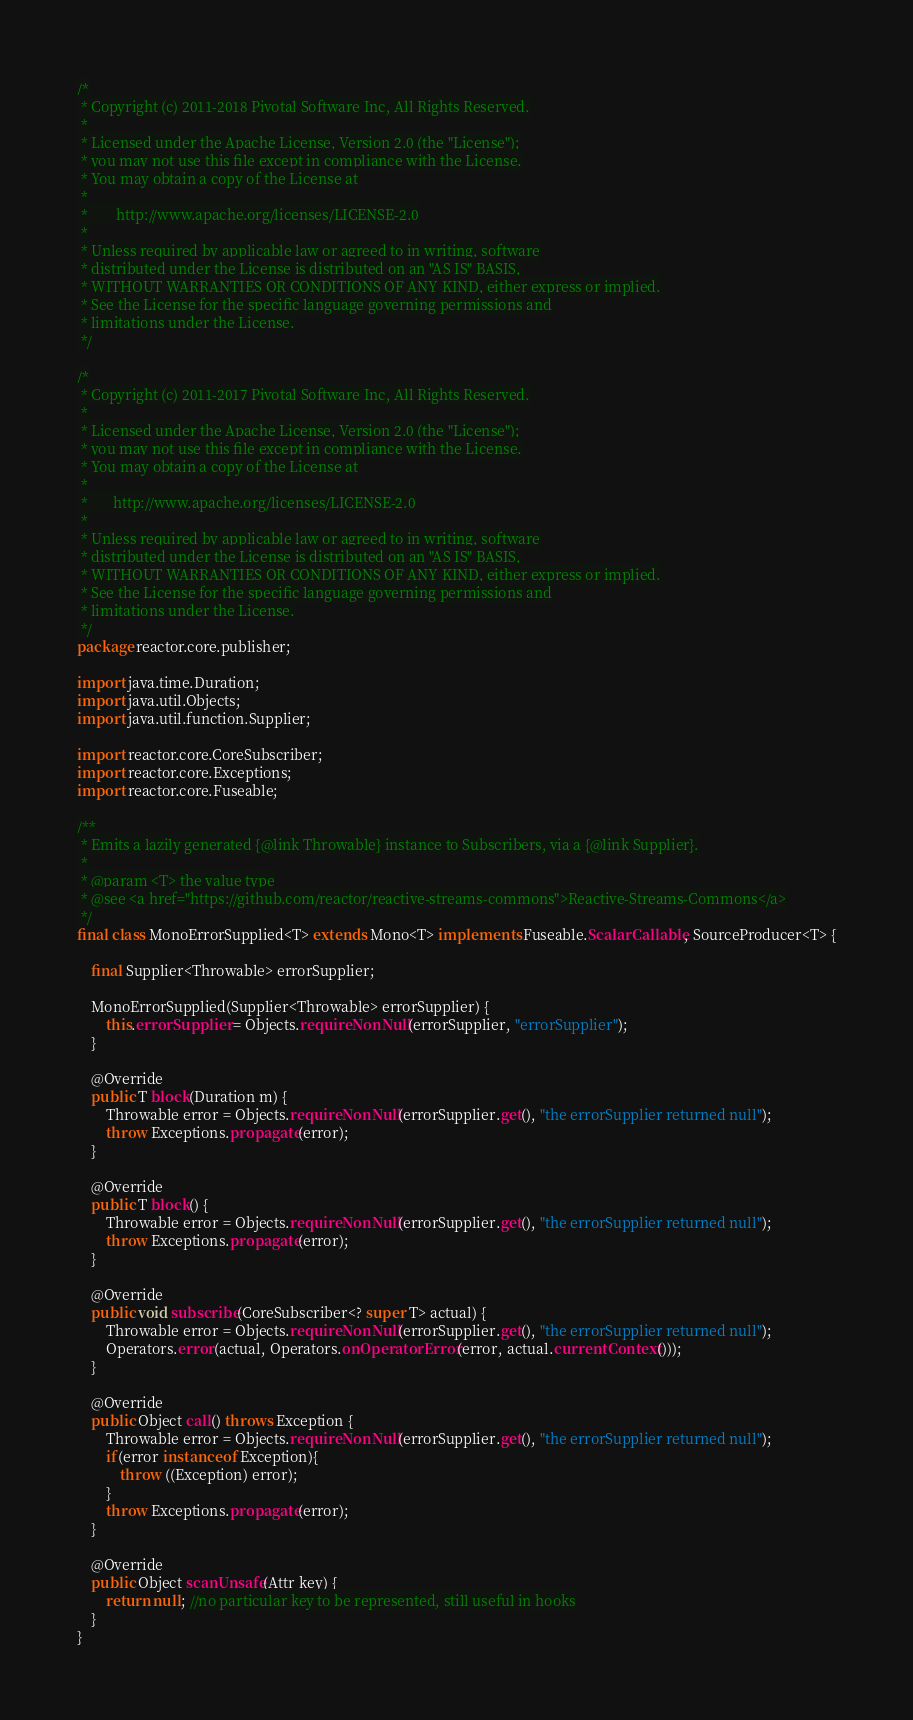<code> <loc_0><loc_0><loc_500><loc_500><_Java_>/*
 * Copyright (c) 2011-2018 Pivotal Software Inc, All Rights Reserved.
 *
 * Licensed under the Apache License, Version 2.0 (the "License");
 * you may not use this file except in compliance with the License.
 * You may obtain a copy of the License at
 *
 *        http://www.apache.org/licenses/LICENSE-2.0
 *
 * Unless required by applicable law or agreed to in writing, software
 * distributed under the License is distributed on an "AS IS" BASIS,
 * WITHOUT WARRANTIES OR CONDITIONS OF ANY KIND, either express or implied.
 * See the License for the specific language governing permissions and
 * limitations under the License.
 */

/*
 * Copyright (c) 2011-2017 Pivotal Software Inc, All Rights Reserved.
 *
 * Licensed under the Apache License, Version 2.0 (the "License");
 * you may not use this file except in compliance with the License.
 * You may obtain a copy of the License at
 *
 *       http://www.apache.org/licenses/LICENSE-2.0
 *
 * Unless required by applicable law or agreed to in writing, software
 * distributed under the License is distributed on an "AS IS" BASIS,
 * WITHOUT WARRANTIES OR CONDITIONS OF ANY KIND, either express or implied.
 * See the License for the specific language governing permissions and
 * limitations under the License.
 */
package reactor.core.publisher;

import java.time.Duration;
import java.util.Objects;
import java.util.function.Supplier;

import reactor.core.CoreSubscriber;
import reactor.core.Exceptions;
import reactor.core.Fuseable;

/**
 * Emits a lazily generated {@link Throwable} instance to Subscribers, via a {@link Supplier}.
 *
 * @param <T> the value type
 * @see <a href="https://github.com/reactor/reactive-streams-commons">Reactive-Streams-Commons</a>
 */
final class MonoErrorSupplied<T> extends Mono<T> implements Fuseable.ScalarCallable, SourceProducer<T> {

	final Supplier<Throwable> errorSupplier;

	MonoErrorSupplied(Supplier<Throwable> errorSupplier) {
		this.errorSupplier = Objects.requireNonNull(errorSupplier, "errorSupplier");
	}

	@Override
	public T block(Duration m) {
		Throwable error = Objects.requireNonNull(errorSupplier.get(), "the errorSupplier returned null");
		throw Exceptions.propagate(error);
	}

	@Override
	public T block() {
		Throwable error = Objects.requireNonNull(errorSupplier.get(), "the errorSupplier returned null");
		throw Exceptions.propagate(error);
	}

	@Override
	public void subscribe(CoreSubscriber<? super T> actual) {
		Throwable error = Objects.requireNonNull(errorSupplier.get(), "the errorSupplier returned null");
		Operators.error(actual, Operators.onOperatorError(error, actual.currentContext()));
	}

	@Override
	public Object call() throws Exception {
		Throwable error = Objects.requireNonNull(errorSupplier.get(), "the errorSupplier returned null");
		if(error instanceof Exception){
			throw ((Exception) error);
		}
		throw Exceptions.propagate(error);
	}

	@Override
	public Object scanUnsafe(Attr key) {
		return null; //no particular key to be represented, still useful in hooks
	}
}
</code> 